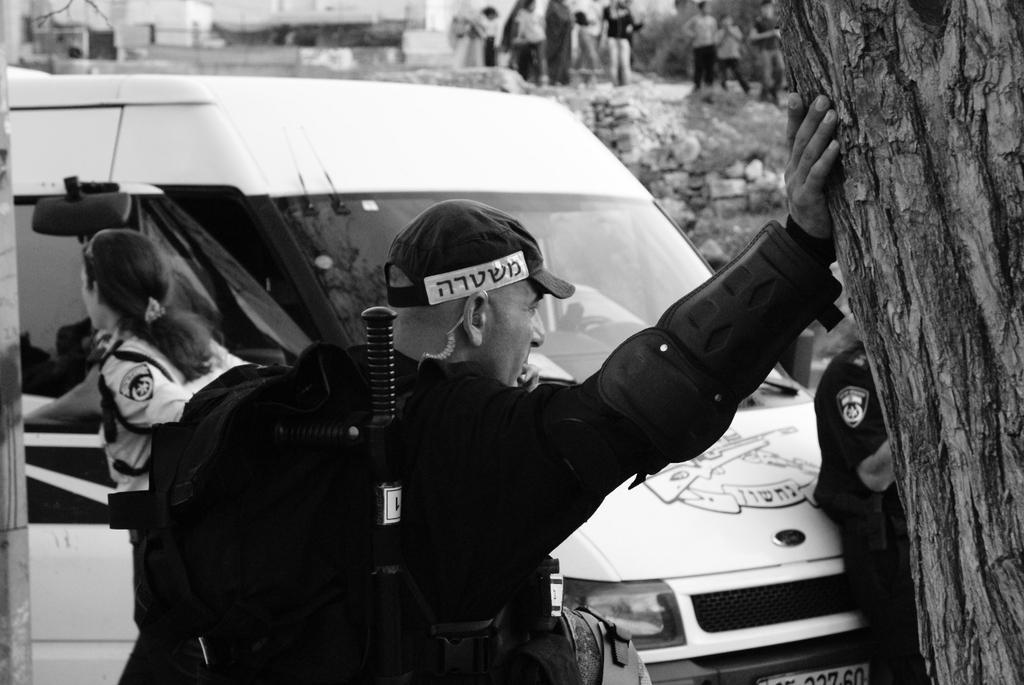How would you summarize this image in a sentence or two? It is a black and white picture. In this picture there are people, vehicle, rocks, branch and objects. In the background of the image it is blurry and there are people.  